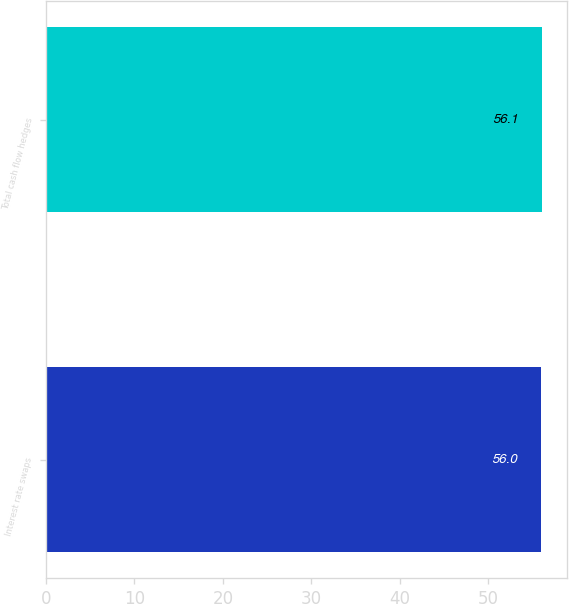<chart> <loc_0><loc_0><loc_500><loc_500><bar_chart><fcel>Interest rate swaps<fcel>Total cash flow hedges<nl><fcel>56<fcel>56.1<nl></chart> 